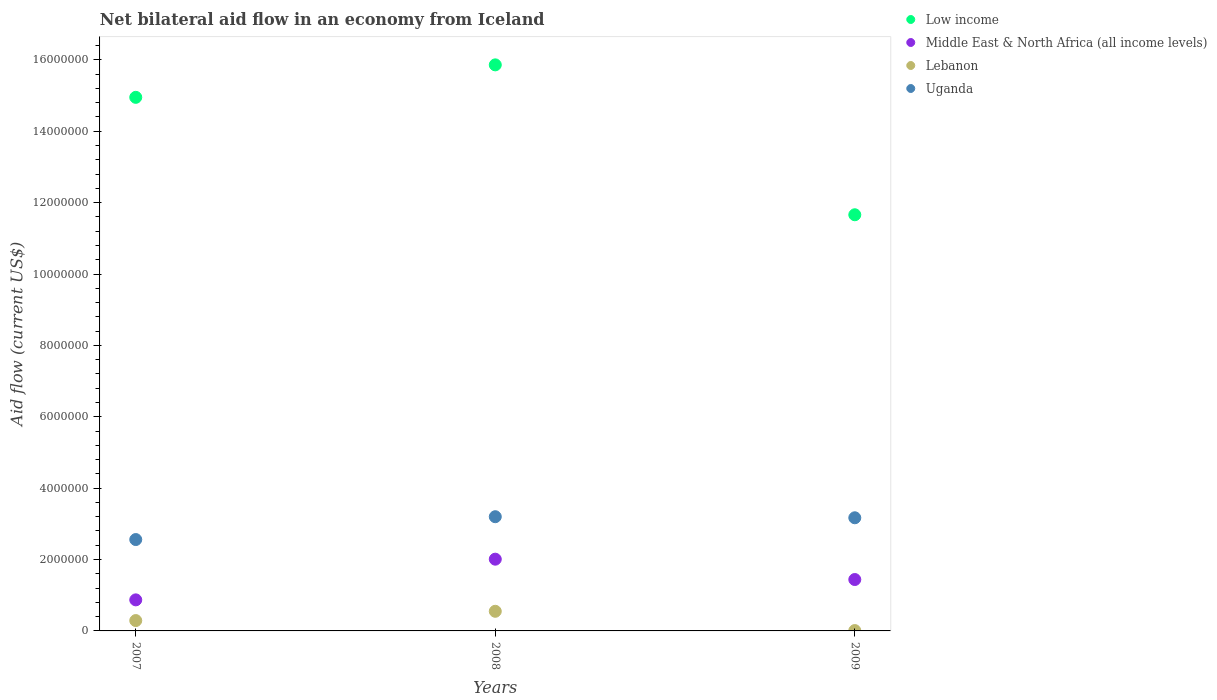How many different coloured dotlines are there?
Ensure brevity in your answer.  4. Across all years, what is the maximum net bilateral aid flow in Uganda?
Make the answer very short. 3.20e+06. Across all years, what is the minimum net bilateral aid flow in Uganda?
Your answer should be very brief. 2.56e+06. What is the total net bilateral aid flow in Lebanon in the graph?
Ensure brevity in your answer.  8.50e+05. What is the difference between the net bilateral aid flow in Low income in 2008 and the net bilateral aid flow in Lebanon in 2009?
Give a very brief answer. 1.58e+07. What is the average net bilateral aid flow in Lebanon per year?
Provide a succinct answer. 2.83e+05. In the year 2007, what is the difference between the net bilateral aid flow in Low income and net bilateral aid flow in Lebanon?
Your answer should be compact. 1.47e+07. In how many years, is the net bilateral aid flow in Lebanon greater than 7600000 US$?
Provide a succinct answer. 0. What is the ratio of the net bilateral aid flow in Low income in 2007 to that in 2009?
Ensure brevity in your answer.  1.28. Is the net bilateral aid flow in Lebanon in 2007 less than that in 2009?
Offer a terse response. No. Is the difference between the net bilateral aid flow in Low income in 2007 and 2009 greater than the difference between the net bilateral aid flow in Lebanon in 2007 and 2009?
Make the answer very short. Yes. What is the difference between the highest and the lowest net bilateral aid flow in Low income?
Make the answer very short. 4.20e+06. Is the sum of the net bilateral aid flow in Lebanon in 2007 and 2008 greater than the maximum net bilateral aid flow in Middle East & North Africa (all income levels) across all years?
Make the answer very short. No. Is the net bilateral aid flow in Low income strictly less than the net bilateral aid flow in Middle East & North Africa (all income levels) over the years?
Provide a short and direct response. No. What is the difference between two consecutive major ticks on the Y-axis?
Your response must be concise. 2.00e+06. Are the values on the major ticks of Y-axis written in scientific E-notation?
Keep it short and to the point. No. Does the graph contain any zero values?
Your response must be concise. No. How many legend labels are there?
Make the answer very short. 4. How are the legend labels stacked?
Make the answer very short. Vertical. What is the title of the graph?
Provide a short and direct response. Net bilateral aid flow in an economy from Iceland. Does "Lebanon" appear as one of the legend labels in the graph?
Provide a short and direct response. Yes. What is the label or title of the X-axis?
Your answer should be very brief. Years. What is the Aid flow (current US$) of Low income in 2007?
Make the answer very short. 1.50e+07. What is the Aid flow (current US$) in Middle East & North Africa (all income levels) in 2007?
Your answer should be very brief. 8.70e+05. What is the Aid flow (current US$) of Lebanon in 2007?
Your response must be concise. 2.90e+05. What is the Aid flow (current US$) in Uganda in 2007?
Your answer should be very brief. 2.56e+06. What is the Aid flow (current US$) of Low income in 2008?
Offer a very short reply. 1.59e+07. What is the Aid flow (current US$) of Middle East & North Africa (all income levels) in 2008?
Your response must be concise. 2.01e+06. What is the Aid flow (current US$) in Uganda in 2008?
Offer a terse response. 3.20e+06. What is the Aid flow (current US$) of Low income in 2009?
Offer a very short reply. 1.17e+07. What is the Aid flow (current US$) of Middle East & North Africa (all income levels) in 2009?
Your response must be concise. 1.44e+06. What is the Aid flow (current US$) of Uganda in 2009?
Offer a very short reply. 3.17e+06. Across all years, what is the maximum Aid flow (current US$) in Low income?
Provide a short and direct response. 1.59e+07. Across all years, what is the maximum Aid flow (current US$) of Middle East & North Africa (all income levels)?
Keep it short and to the point. 2.01e+06. Across all years, what is the maximum Aid flow (current US$) of Uganda?
Ensure brevity in your answer.  3.20e+06. Across all years, what is the minimum Aid flow (current US$) in Low income?
Keep it short and to the point. 1.17e+07. Across all years, what is the minimum Aid flow (current US$) of Middle East & North Africa (all income levels)?
Your answer should be very brief. 8.70e+05. Across all years, what is the minimum Aid flow (current US$) in Uganda?
Offer a terse response. 2.56e+06. What is the total Aid flow (current US$) of Low income in the graph?
Offer a very short reply. 4.25e+07. What is the total Aid flow (current US$) of Middle East & North Africa (all income levels) in the graph?
Keep it short and to the point. 4.32e+06. What is the total Aid flow (current US$) of Lebanon in the graph?
Ensure brevity in your answer.  8.50e+05. What is the total Aid flow (current US$) in Uganda in the graph?
Your response must be concise. 8.93e+06. What is the difference between the Aid flow (current US$) of Low income in 2007 and that in 2008?
Give a very brief answer. -9.10e+05. What is the difference between the Aid flow (current US$) of Middle East & North Africa (all income levels) in 2007 and that in 2008?
Your response must be concise. -1.14e+06. What is the difference between the Aid flow (current US$) of Lebanon in 2007 and that in 2008?
Your answer should be compact. -2.60e+05. What is the difference between the Aid flow (current US$) of Uganda in 2007 and that in 2008?
Your answer should be very brief. -6.40e+05. What is the difference between the Aid flow (current US$) of Low income in 2007 and that in 2009?
Offer a terse response. 3.29e+06. What is the difference between the Aid flow (current US$) in Middle East & North Africa (all income levels) in 2007 and that in 2009?
Give a very brief answer. -5.70e+05. What is the difference between the Aid flow (current US$) of Uganda in 2007 and that in 2009?
Provide a succinct answer. -6.10e+05. What is the difference between the Aid flow (current US$) of Low income in 2008 and that in 2009?
Keep it short and to the point. 4.20e+06. What is the difference between the Aid flow (current US$) in Middle East & North Africa (all income levels) in 2008 and that in 2009?
Offer a very short reply. 5.70e+05. What is the difference between the Aid flow (current US$) in Lebanon in 2008 and that in 2009?
Your response must be concise. 5.40e+05. What is the difference between the Aid flow (current US$) of Low income in 2007 and the Aid flow (current US$) of Middle East & North Africa (all income levels) in 2008?
Make the answer very short. 1.29e+07. What is the difference between the Aid flow (current US$) of Low income in 2007 and the Aid flow (current US$) of Lebanon in 2008?
Offer a very short reply. 1.44e+07. What is the difference between the Aid flow (current US$) in Low income in 2007 and the Aid flow (current US$) in Uganda in 2008?
Provide a succinct answer. 1.18e+07. What is the difference between the Aid flow (current US$) in Middle East & North Africa (all income levels) in 2007 and the Aid flow (current US$) in Uganda in 2008?
Provide a short and direct response. -2.33e+06. What is the difference between the Aid flow (current US$) in Lebanon in 2007 and the Aid flow (current US$) in Uganda in 2008?
Your answer should be very brief. -2.91e+06. What is the difference between the Aid flow (current US$) of Low income in 2007 and the Aid flow (current US$) of Middle East & North Africa (all income levels) in 2009?
Keep it short and to the point. 1.35e+07. What is the difference between the Aid flow (current US$) of Low income in 2007 and the Aid flow (current US$) of Lebanon in 2009?
Your answer should be very brief. 1.49e+07. What is the difference between the Aid flow (current US$) of Low income in 2007 and the Aid flow (current US$) of Uganda in 2009?
Offer a very short reply. 1.18e+07. What is the difference between the Aid flow (current US$) of Middle East & North Africa (all income levels) in 2007 and the Aid flow (current US$) of Lebanon in 2009?
Your answer should be compact. 8.60e+05. What is the difference between the Aid flow (current US$) in Middle East & North Africa (all income levels) in 2007 and the Aid flow (current US$) in Uganda in 2009?
Your answer should be very brief. -2.30e+06. What is the difference between the Aid flow (current US$) in Lebanon in 2007 and the Aid flow (current US$) in Uganda in 2009?
Provide a short and direct response. -2.88e+06. What is the difference between the Aid flow (current US$) in Low income in 2008 and the Aid flow (current US$) in Middle East & North Africa (all income levels) in 2009?
Your answer should be very brief. 1.44e+07. What is the difference between the Aid flow (current US$) of Low income in 2008 and the Aid flow (current US$) of Lebanon in 2009?
Your response must be concise. 1.58e+07. What is the difference between the Aid flow (current US$) of Low income in 2008 and the Aid flow (current US$) of Uganda in 2009?
Ensure brevity in your answer.  1.27e+07. What is the difference between the Aid flow (current US$) of Middle East & North Africa (all income levels) in 2008 and the Aid flow (current US$) of Uganda in 2009?
Provide a short and direct response. -1.16e+06. What is the difference between the Aid flow (current US$) in Lebanon in 2008 and the Aid flow (current US$) in Uganda in 2009?
Your answer should be very brief. -2.62e+06. What is the average Aid flow (current US$) of Low income per year?
Provide a succinct answer. 1.42e+07. What is the average Aid flow (current US$) of Middle East & North Africa (all income levels) per year?
Make the answer very short. 1.44e+06. What is the average Aid flow (current US$) in Lebanon per year?
Keep it short and to the point. 2.83e+05. What is the average Aid flow (current US$) of Uganda per year?
Provide a succinct answer. 2.98e+06. In the year 2007, what is the difference between the Aid flow (current US$) in Low income and Aid flow (current US$) in Middle East & North Africa (all income levels)?
Provide a short and direct response. 1.41e+07. In the year 2007, what is the difference between the Aid flow (current US$) of Low income and Aid flow (current US$) of Lebanon?
Keep it short and to the point. 1.47e+07. In the year 2007, what is the difference between the Aid flow (current US$) of Low income and Aid flow (current US$) of Uganda?
Provide a short and direct response. 1.24e+07. In the year 2007, what is the difference between the Aid flow (current US$) in Middle East & North Africa (all income levels) and Aid flow (current US$) in Lebanon?
Ensure brevity in your answer.  5.80e+05. In the year 2007, what is the difference between the Aid flow (current US$) of Middle East & North Africa (all income levels) and Aid flow (current US$) of Uganda?
Your answer should be compact. -1.69e+06. In the year 2007, what is the difference between the Aid flow (current US$) of Lebanon and Aid flow (current US$) of Uganda?
Ensure brevity in your answer.  -2.27e+06. In the year 2008, what is the difference between the Aid flow (current US$) of Low income and Aid flow (current US$) of Middle East & North Africa (all income levels)?
Provide a succinct answer. 1.38e+07. In the year 2008, what is the difference between the Aid flow (current US$) in Low income and Aid flow (current US$) in Lebanon?
Offer a terse response. 1.53e+07. In the year 2008, what is the difference between the Aid flow (current US$) of Low income and Aid flow (current US$) of Uganda?
Provide a succinct answer. 1.27e+07. In the year 2008, what is the difference between the Aid flow (current US$) in Middle East & North Africa (all income levels) and Aid flow (current US$) in Lebanon?
Provide a succinct answer. 1.46e+06. In the year 2008, what is the difference between the Aid flow (current US$) in Middle East & North Africa (all income levels) and Aid flow (current US$) in Uganda?
Keep it short and to the point. -1.19e+06. In the year 2008, what is the difference between the Aid flow (current US$) in Lebanon and Aid flow (current US$) in Uganda?
Provide a succinct answer. -2.65e+06. In the year 2009, what is the difference between the Aid flow (current US$) in Low income and Aid flow (current US$) in Middle East & North Africa (all income levels)?
Offer a very short reply. 1.02e+07. In the year 2009, what is the difference between the Aid flow (current US$) in Low income and Aid flow (current US$) in Lebanon?
Offer a very short reply. 1.16e+07. In the year 2009, what is the difference between the Aid flow (current US$) of Low income and Aid flow (current US$) of Uganda?
Your answer should be compact. 8.49e+06. In the year 2009, what is the difference between the Aid flow (current US$) of Middle East & North Africa (all income levels) and Aid flow (current US$) of Lebanon?
Offer a terse response. 1.43e+06. In the year 2009, what is the difference between the Aid flow (current US$) in Middle East & North Africa (all income levels) and Aid flow (current US$) in Uganda?
Offer a terse response. -1.73e+06. In the year 2009, what is the difference between the Aid flow (current US$) of Lebanon and Aid flow (current US$) of Uganda?
Provide a short and direct response. -3.16e+06. What is the ratio of the Aid flow (current US$) in Low income in 2007 to that in 2008?
Provide a succinct answer. 0.94. What is the ratio of the Aid flow (current US$) in Middle East & North Africa (all income levels) in 2007 to that in 2008?
Your response must be concise. 0.43. What is the ratio of the Aid flow (current US$) of Lebanon in 2007 to that in 2008?
Keep it short and to the point. 0.53. What is the ratio of the Aid flow (current US$) of Low income in 2007 to that in 2009?
Your response must be concise. 1.28. What is the ratio of the Aid flow (current US$) of Middle East & North Africa (all income levels) in 2007 to that in 2009?
Provide a succinct answer. 0.6. What is the ratio of the Aid flow (current US$) of Uganda in 2007 to that in 2009?
Keep it short and to the point. 0.81. What is the ratio of the Aid flow (current US$) in Low income in 2008 to that in 2009?
Make the answer very short. 1.36. What is the ratio of the Aid flow (current US$) of Middle East & North Africa (all income levels) in 2008 to that in 2009?
Keep it short and to the point. 1.4. What is the ratio of the Aid flow (current US$) in Lebanon in 2008 to that in 2009?
Provide a succinct answer. 55. What is the ratio of the Aid flow (current US$) in Uganda in 2008 to that in 2009?
Keep it short and to the point. 1.01. What is the difference between the highest and the second highest Aid flow (current US$) of Low income?
Give a very brief answer. 9.10e+05. What is the difference between the highest and the second highest Aid flow (current US$) in Middle East & North Africa (all income levels)?
Give a very brief answer. 5.70e+05. What is the difference between the highest and the second highest Aid flow (current US$) of Lebanon?
Offer a very short reply. 2.60e+05. What is the difference between the highest and the lowest Aid flow (current US$) in Low income?
Offer a very short reply. 4.20e+06. What is the difference between the highest and the lowest Aid flow (current US$) in Middle East & North Africa (all income levels)?
Offer a terse response. 1.14e+06. What is the difference between the highest and the lowest Aid flow (current US$) of Lebanon?
Make the answer very short. 5.40e+05. What is the difference between the highest and the lowest Aid flow (current US$) in Uganda?
Your answer should be compact. 6.40e+05. 